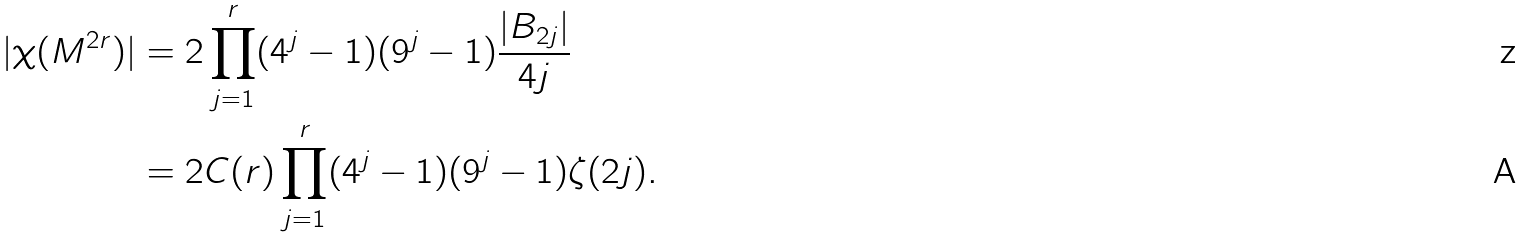<formula> <loc_0><loc_0><loc_500><loc_500>| \chi ( M ^ { 2 r } ) | & = 2 \prod _ { j = 1 } ^ { r } ( 4 ^ { j } - 1 ) ( 9 ^ { j } - 1 ) \frac { | B _ { 2 j } | } { 4 j } \\ & = 2 C ( r ) \prod _ { j = 1 } ^ { r } ( 4 ^ { j } - 1 ) ( 9 ^ { j } - 1 ) \zeta ( 2 j ) .</formula> 